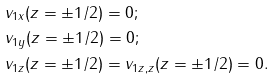Convert formula to latex. <formula><loc_0><loc_0><loc_500><loc_500>& v _ { 1 x } ( z = \pm 1 / 2 ) = 0 ; \\ & v _ { 1 y } ( z = \pm 1 / 2 ) = 0 ; \\ & v _ { 1 z } ( z = \pm 1 / 2 ) = v _ { 1 z , z } ( z = \pm 1 / 2 ) = 0 .</formula> 